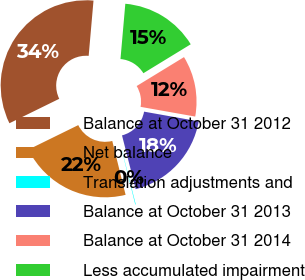<chart> <loc_0><loc_0><loc_500><loc_500><pie_chart><fcel>Balance at October 31 2012<fcel>Net balance<fcel>Translation adjustments and<fcel>Balance at October 31 2013<fcel>Balance at October 31 2014<fcel>Less accumulated impairment<nl><fcel>33.65%<fcel>21.6%<fcel>0.1%<fcel>18.24%<fcel>11.53%<fcel>14.88%<nl></chart> 